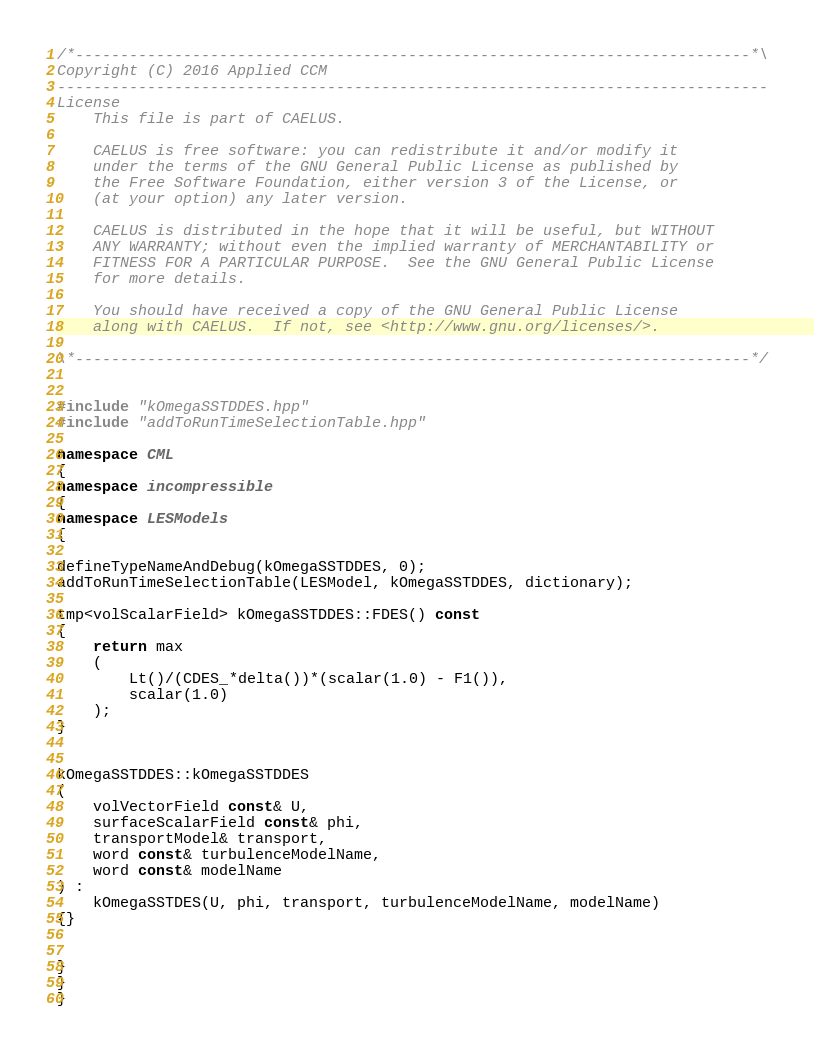Convert code to text. <code><loc_0><loc_0><loc_500><loc_500><_C++_>/*---------------------------------------------------------------------------*\
Copyright (C) 2016 Applied CCM
-------------------------------------------------------------------------------
License
    This file is part of CAELUS.

    CAELUS is free software: you can redistribute it and/or modify it
    under the terms of the GNU General Public License as published by
    the Free Software Foundation, either version 3 of the License, or
    (at your option) any later version.

    CAELUS is distributed in the hope that it will be useful, but WITHOUT
    ANY WARRANTY; without even the implied warranty of MERCHANTABILITY or
    FITNESS FOR A PARTICULAR PURPOSE.  See the GNU General Public License
    for more details.

    You should have received a copy of the GNU General Public License
    along with CAELUS.  If not, see <http://www.gnu.org/licenses/>.

\*---------------------------------------------------------------------------*/


#include "kOmegaSSTDDES.hpp"
#include "addToRunTimeSelectionTable.hpp"

namespace CML
{
namespace incompressible
{
namespace LESModels
{

defineTypeNameAndDebug(kOmegaSSTDDES, 0);
addToRunTimeSelectionTable(LESModel, kOmegaSSTDDES, dictionary);

tmp<volScalarField> kOmegaSSTDDES::FDES() const
{
    return max
    (
        Lt()/(CDES_*delta())*(scalar(1.0) - F1()),
        scalar(1.0)
    );
}


kOmegaSSTDDES::kOmegaSSTDDES
(
    volVectorField const& U,
    surfaceScalarField const& phi,
    transportModel& transport,
    word const& turbulenceModelName,
    word const& modelName
) :
    kOmegaSSTDES(U, phi, transport, turbulenceModelName, modelName)
{}


}
}
}


</code> 